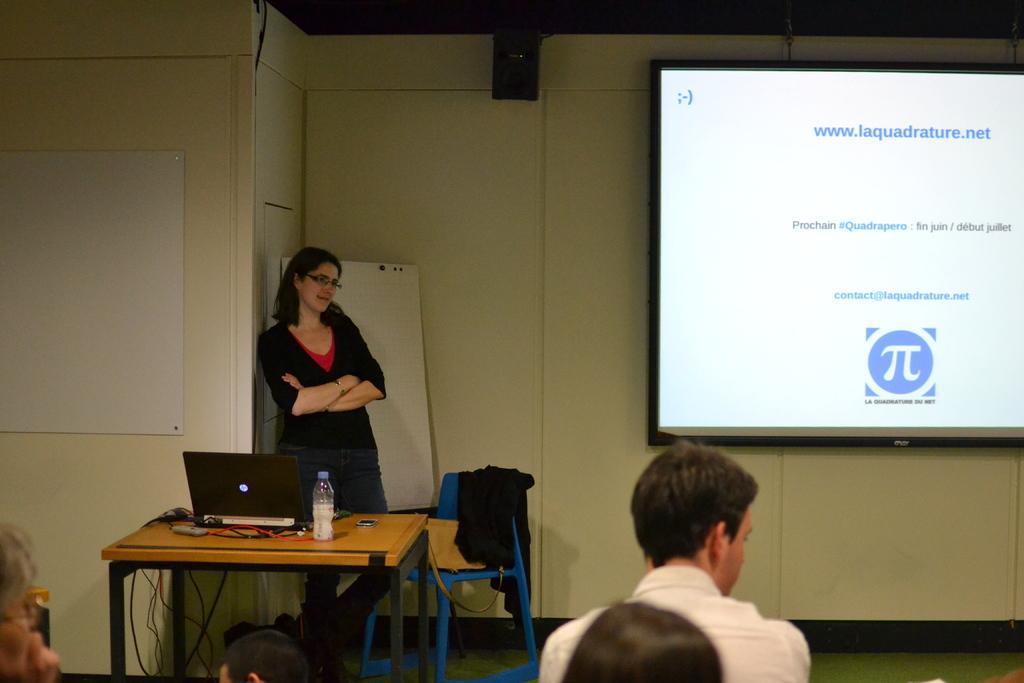How would you summarize this image in a sentence or two? In this image there few people in the room. In front there is woman standing. On the table there is a laptop and a bottle. On the chair there is bag and a coat. At the background there is a wall where the projector is connected to the wall. 